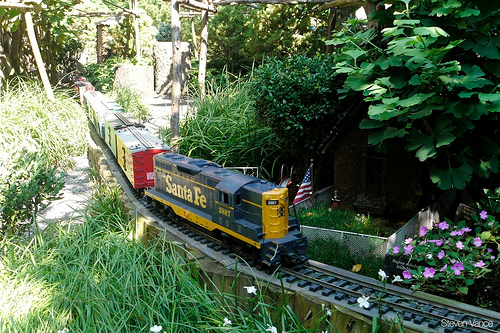Please provide a short description for this region: [0.22, 0.41, 0.32, 0.53]. This region showcases a red train car. 